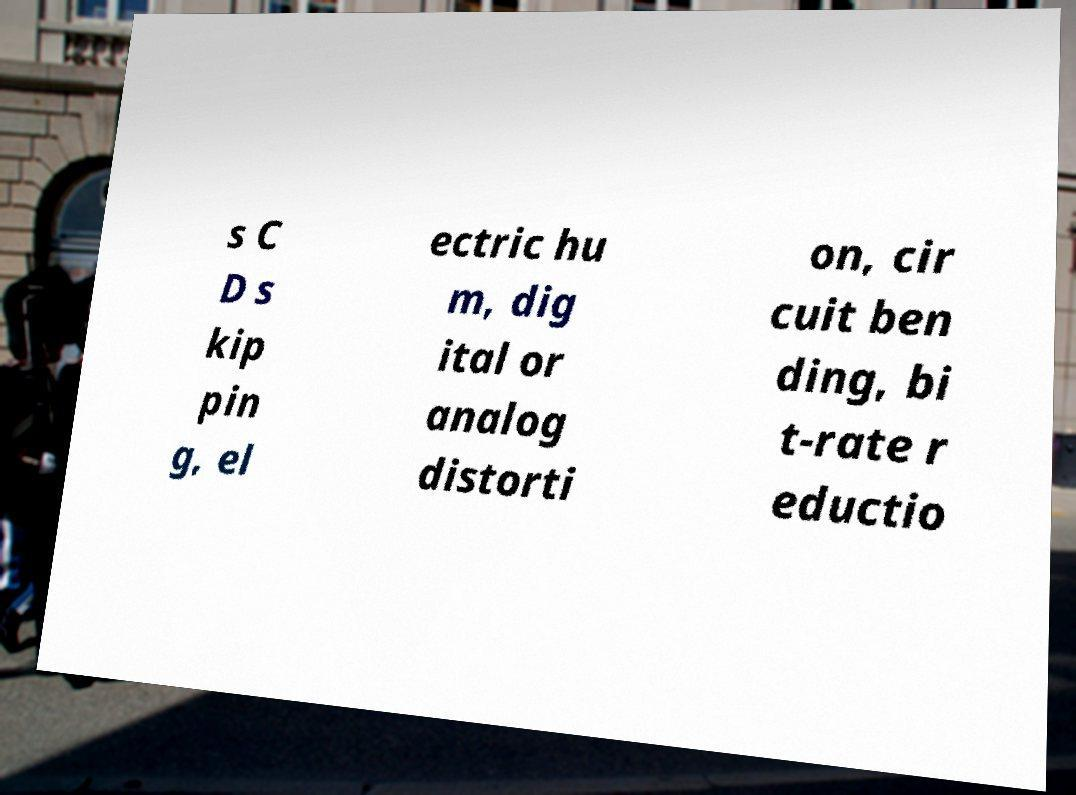I need the written content from this picture converted into text. Can you do that? s C D s kip pin g, el ectric hu m, dig ital or analog distorti on, cir cuit ben ding, bi t-rate r eductio 